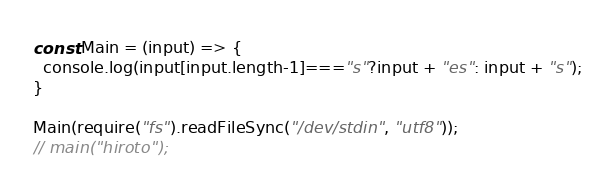<code> <loc_0><loc_0><loc_500><loc_500><_JavaScript_>const Main = (input) => {
  console.log(input[input.length-1]==="s"?input + "es": input + "s");
}

Main(require("fs").readFileSync("/dev/stdin", "utf8"));
// main("hiroto");</code> 